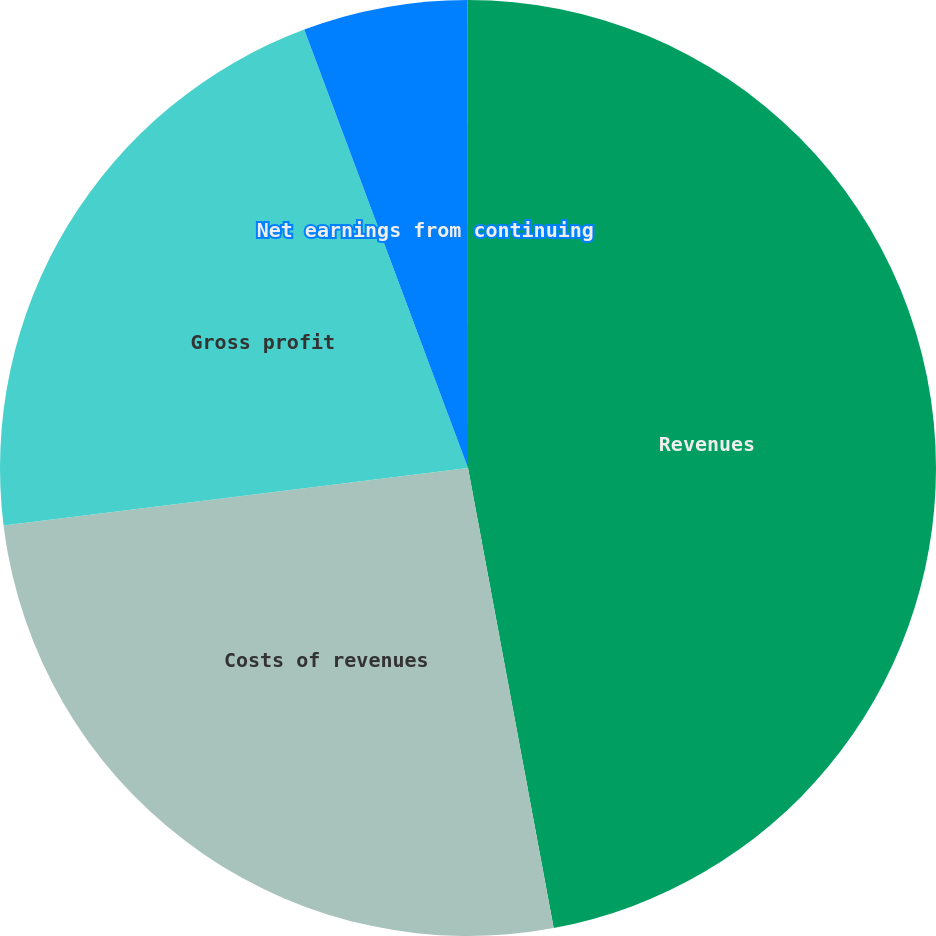Convert chart to OTSL. <chart><loc_0><loc_0><loc_500><loc_500><pie_chart><fcel>Revenues<fcel>Costs of revenues<fcel>Gross profit<fcel>Net earnings from continuing<fcel>continuing operations<nl><fcel>47.07%<fcel>25.97%<fcel>21.27%<fcel>5.68%<fcel>0.01%<nl></chart> 